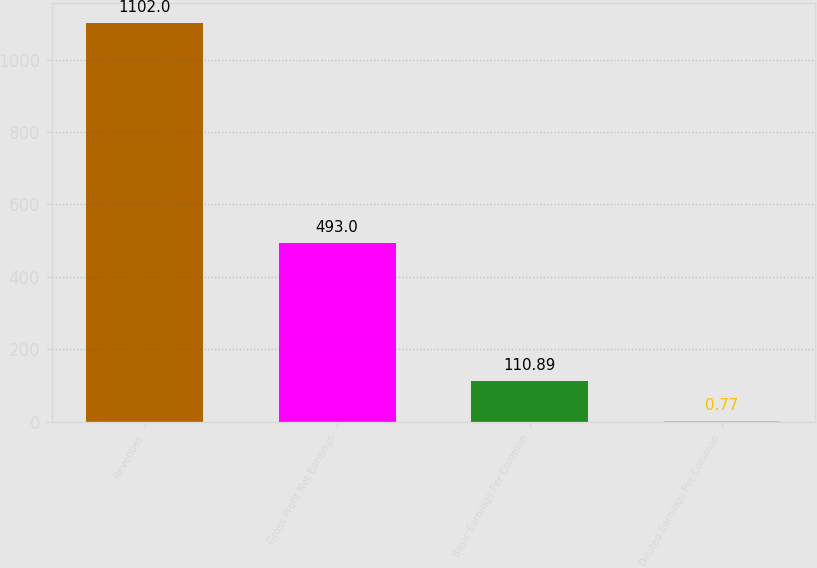Convert chart to OTSL. <chart><loc_0><loc_0><loc_500><loc_500><bar_chart><fcel>Revenues<fcel>Gross Profit Net Earnings<fcel>Basic Earnings Per Common<fcel>Diluted Earnings Per Common<nl><fcel>1102<fcel>493<fcel>110.89<fcel>0.77<nl></chart> 